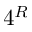Convert formula to latex. <formula><loc_0><loc_0><loc_500><loc_500>4 ^ { R }</formula> 